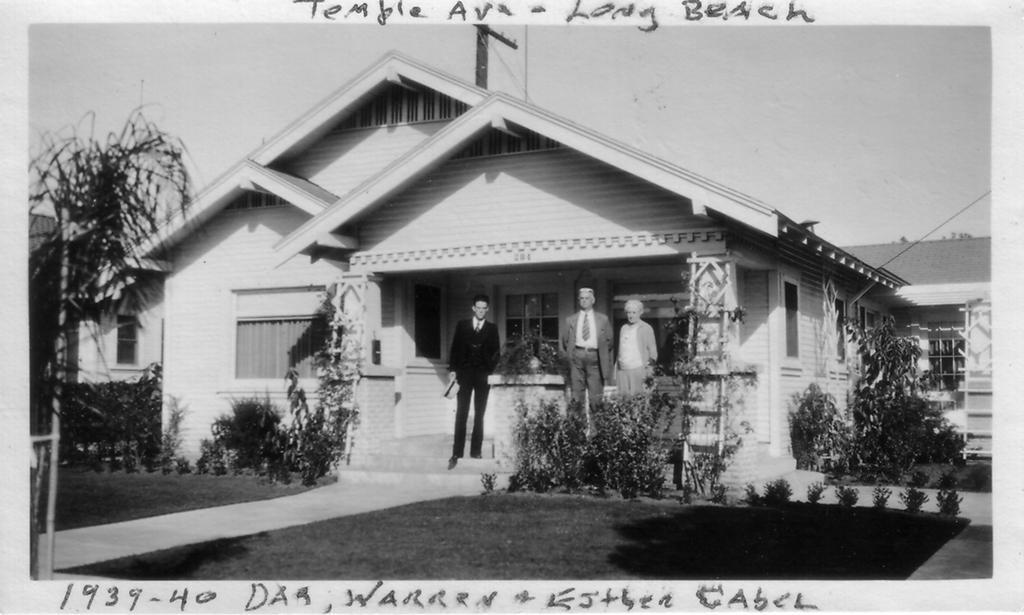Describe this image in one or two sentences. This image is a black and white image where we can see these people are standing here. Here we can see the grass, plants, wooden house, trees and the sky in the background. 